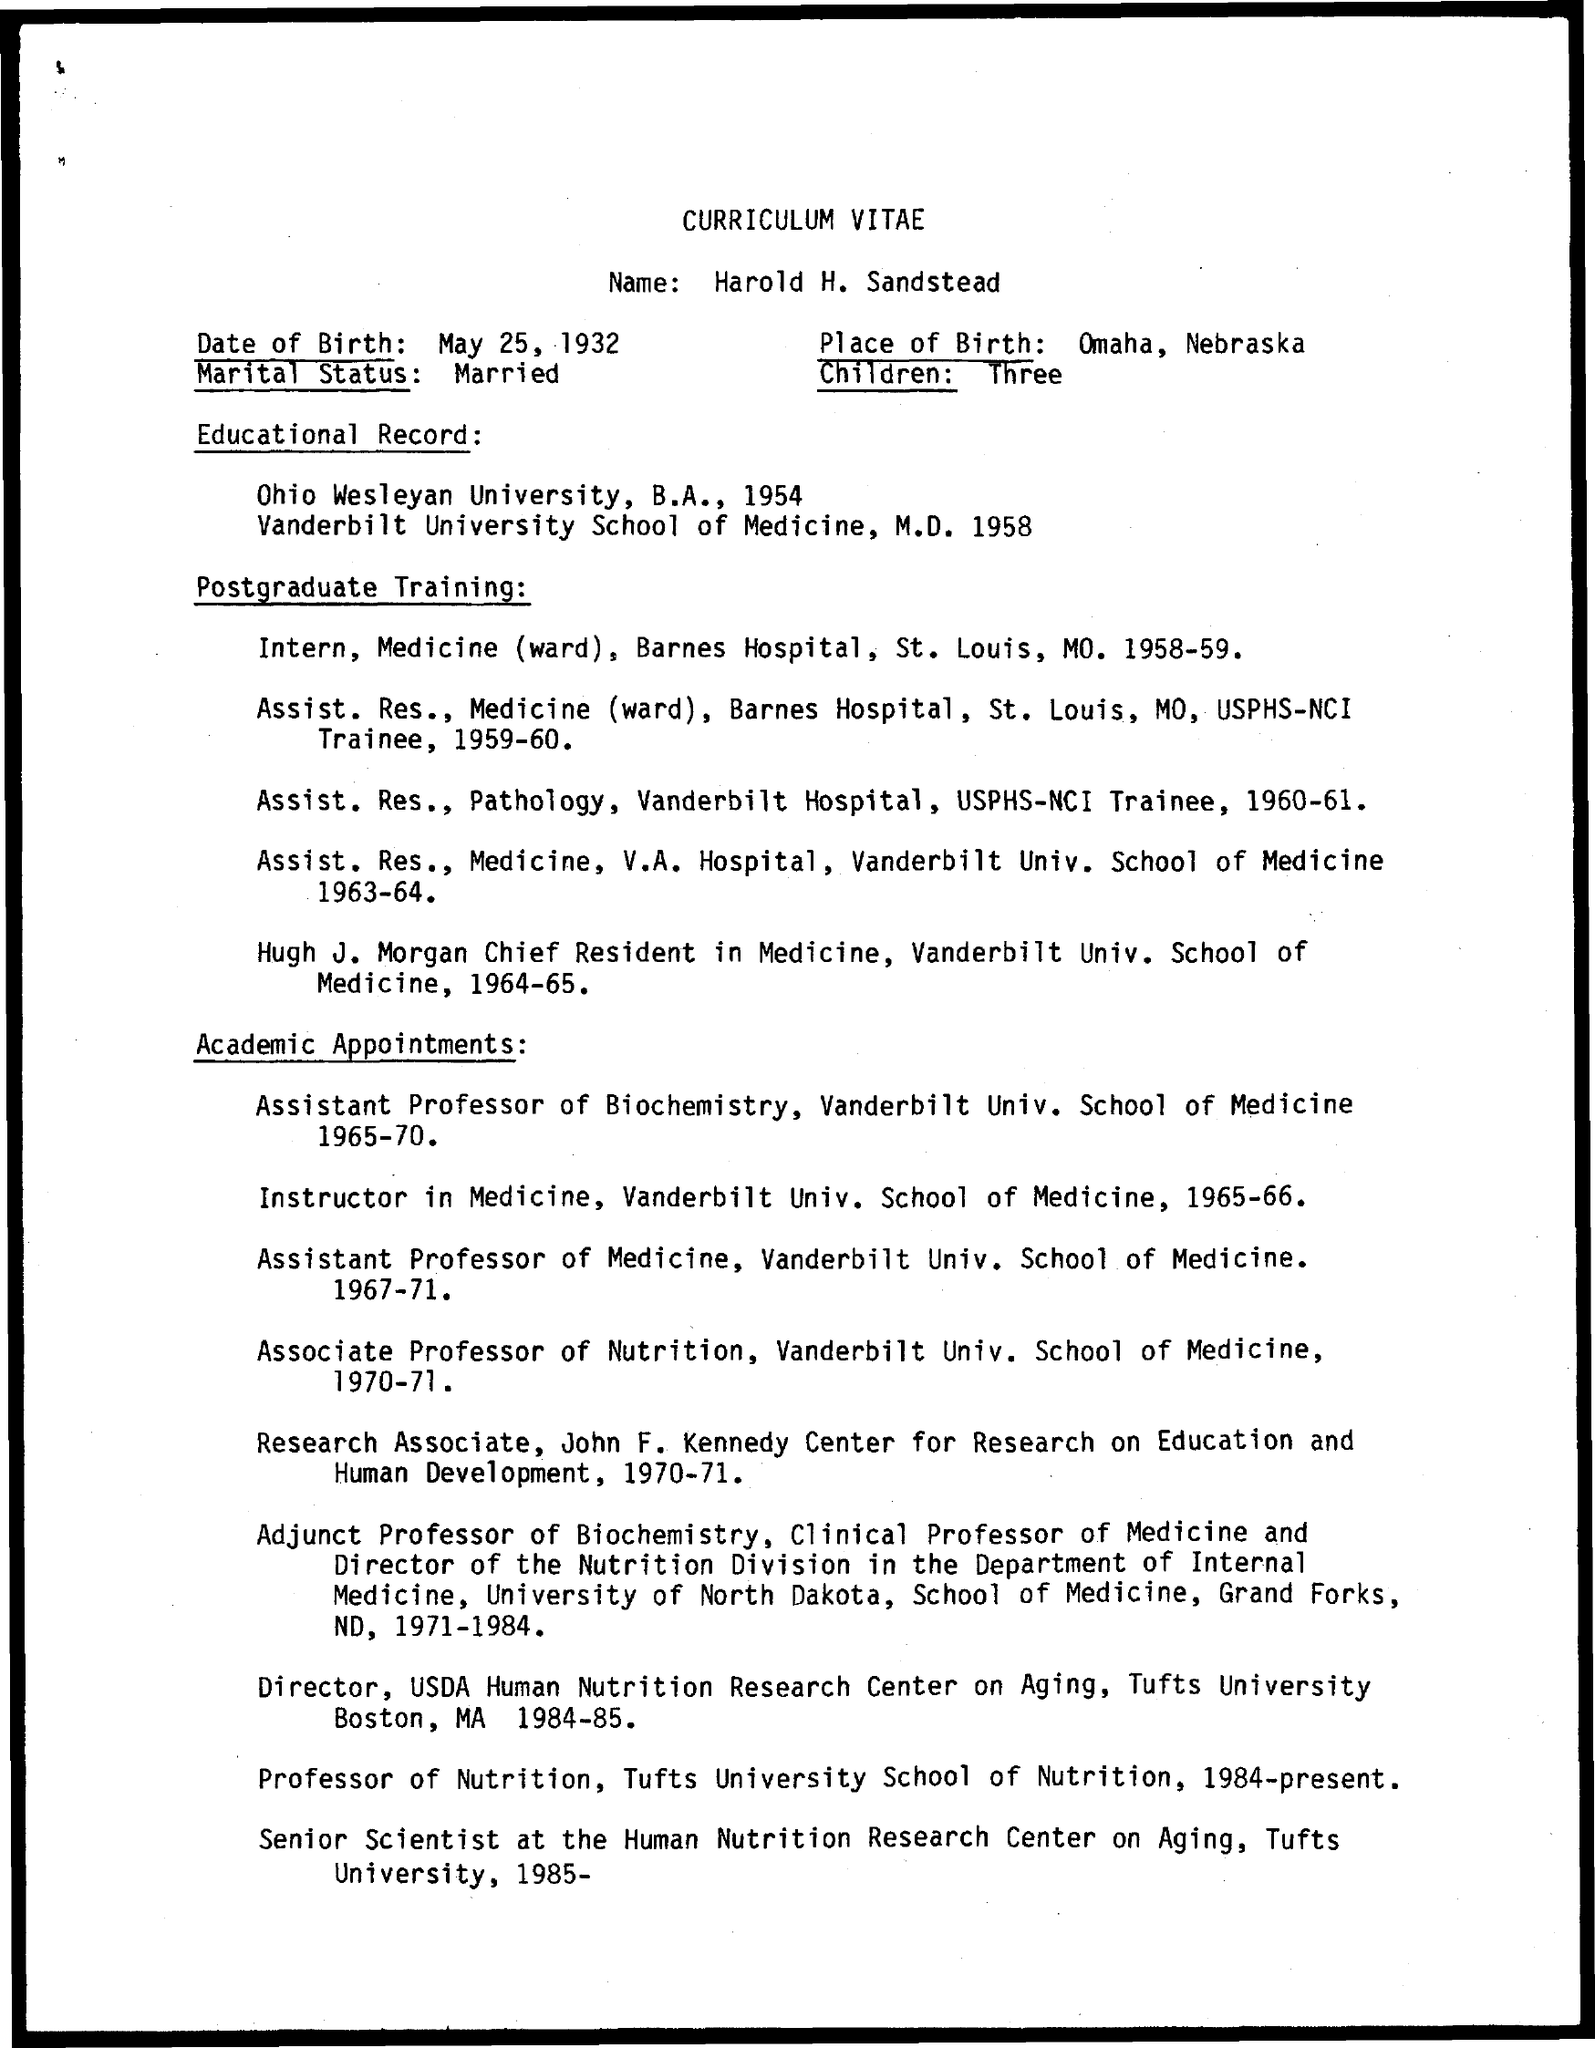Identify some key points in this picture. The place of birth mentioned in the given curriculum vitae is Omaha, Nebraska. The person to whom this curriculum vitae belongs is Harold H. Sandstead. The date of birth mentioned in the given curriculum vitae is May 25, 1932. The marital status mentioned in the curriculum vitae is 'married.' In 1958, Sandstead completed his M.D. in medicine, which is mentioned in his curriculum vitae. 